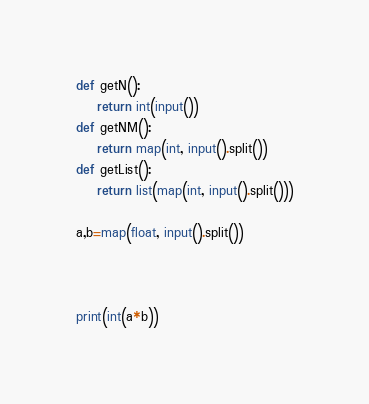<code> <loc_0><loc_0><loc_500><loc_500><_Python_>def getN():
    return int(input())
def getNM():
    return map(int, input().split())
def getList():
    return list(map(int, input().split()))

a,b=map(float, input().split())



print(int(a*b))</code> 